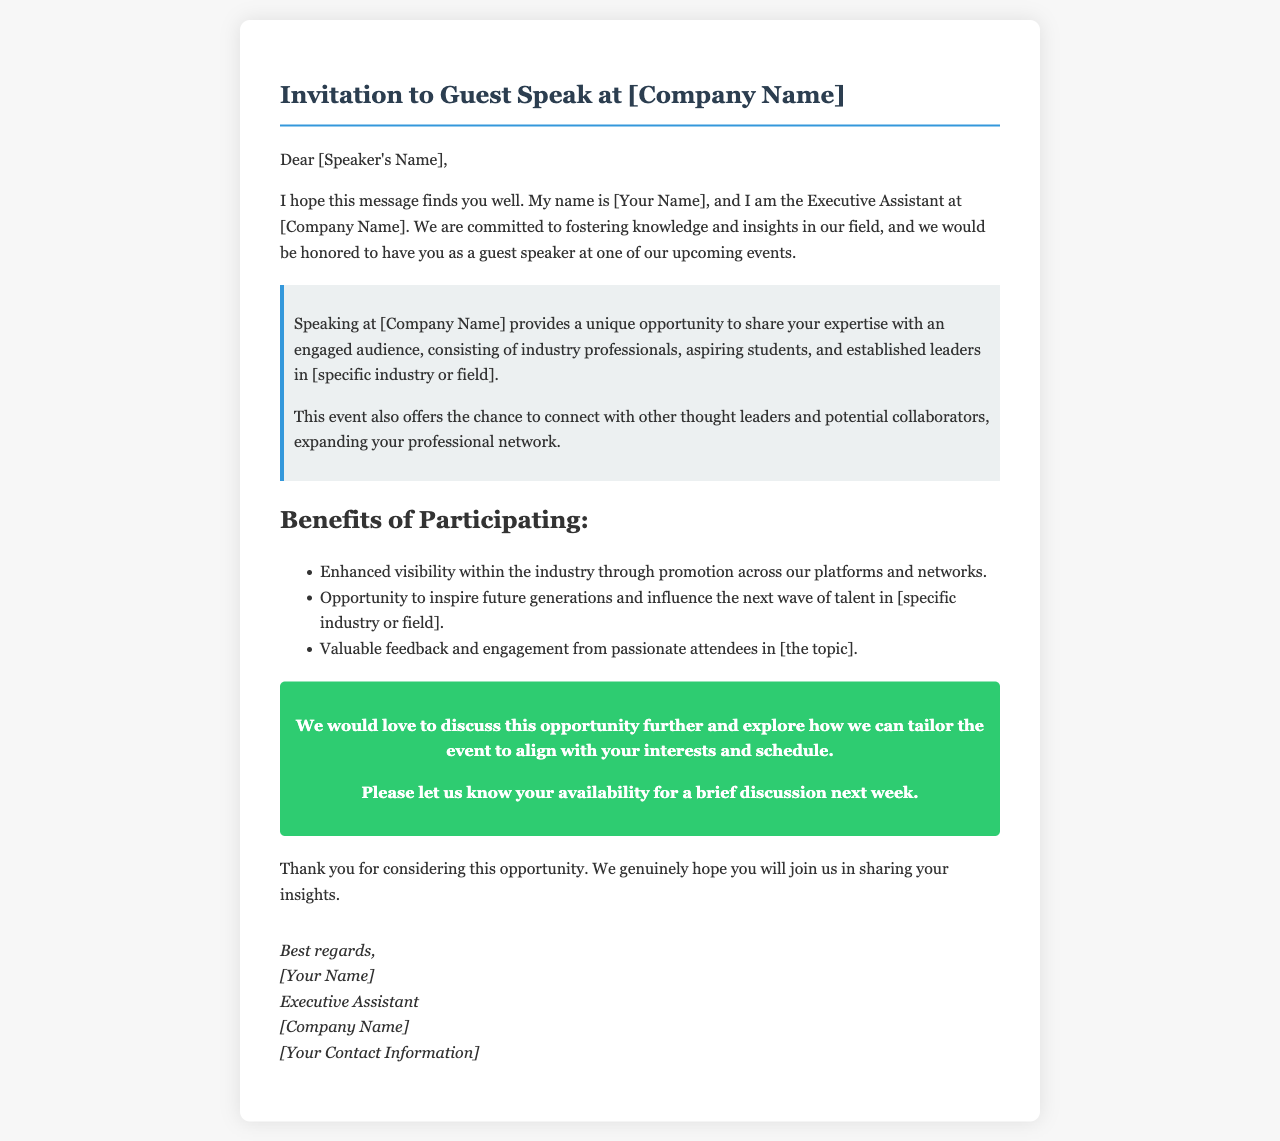What is the title of the letter? The title is clearly stated at the top of the document.
Answer: Invitation to Guest Speak at [Company Name] Who is the sender of the letter? The sender's position and name are mentioned at the end of the letter.
Answer: [Your Name] What is one benefit of participating mentioned in the letter? Benefits are listed in a bullet point format, defining what the speakers gain.
Answer: Enhanced visibility within the industry What is the purpose of this letter? The main aim of the letter is outlined in the introduction.
Answer: To invite a guest speaker What does the highlighted section emphasize? The highlighted section conveys the unique opportunity provided to the speaker.
Answer: Share your expertise with an engaged audience What does the letter encourage the speaker to do? A clear call-to-action is present towards the end of the letter.
Answer: Schedule a discussion How many benefits of participating are listed? The document provides a specific number of benefits in a list.
Answer: Three What type of audience is the speaker expected to engage with? The letter specifies the nature of the audience.
Answer: Industry professionals, aspiring students, and established leaders What is the closing remark of the letter? The closing thoughts encompass gratitude towards the speaker for their consideration.
Answer: Thank you for considering this opportunity 